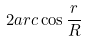Convert formula to latex. <formula><loc_0><loc_0><loc_500><loc_500>2 a r c \cos \frac { r } { R }</formula> 